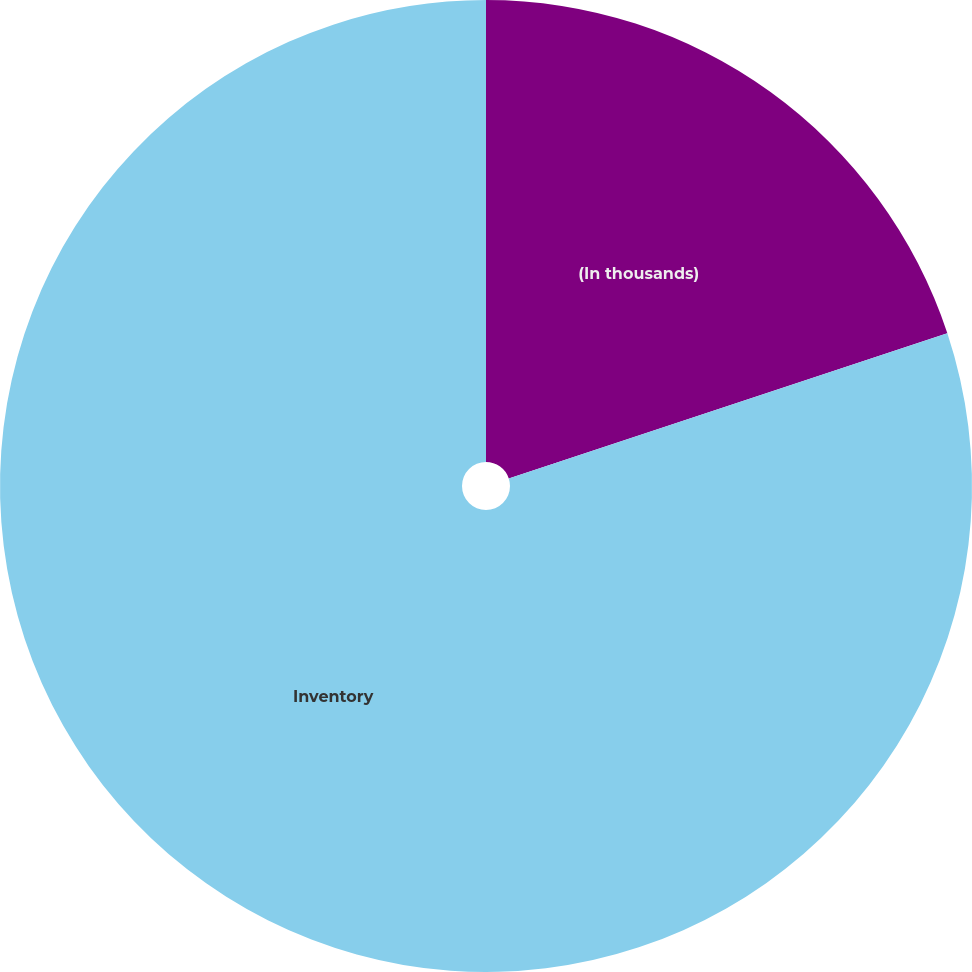<chart> <loc_0><loc_0><loc_500><loc_500><pie_chart><fcel>(In thousands)<fcel>Inventory<nl><fcel>19.91%<fcel>80.09%<nl></chart> 